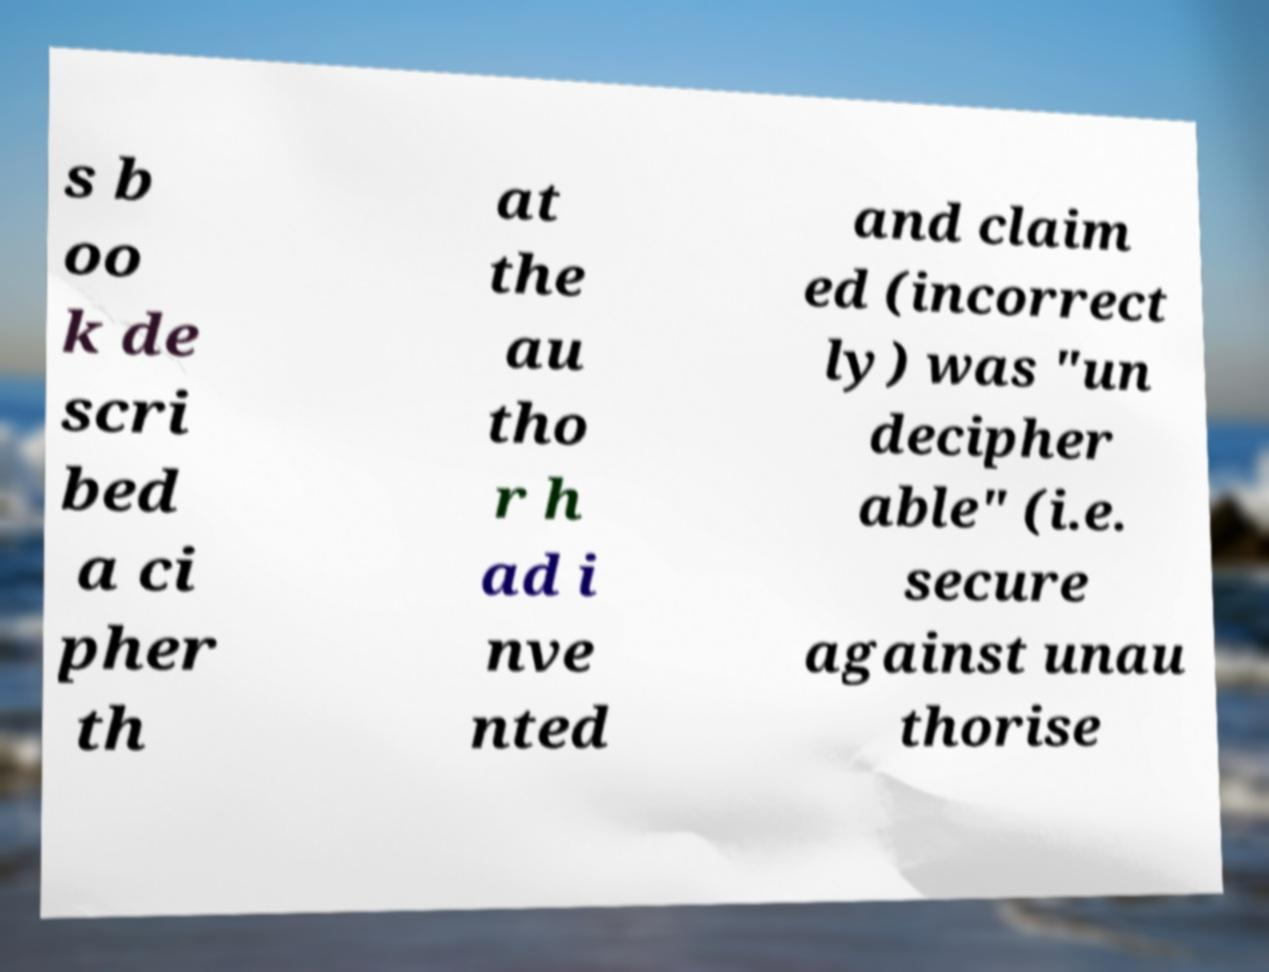Could you assist in decoding the text presented in this image and type it out clearly? s b oo k de scri bed a ci pher th at the au tho r h ad i nve nted and claim ed (incorrect ly) was "un decipher able" (i.e. secure against unau thorise 